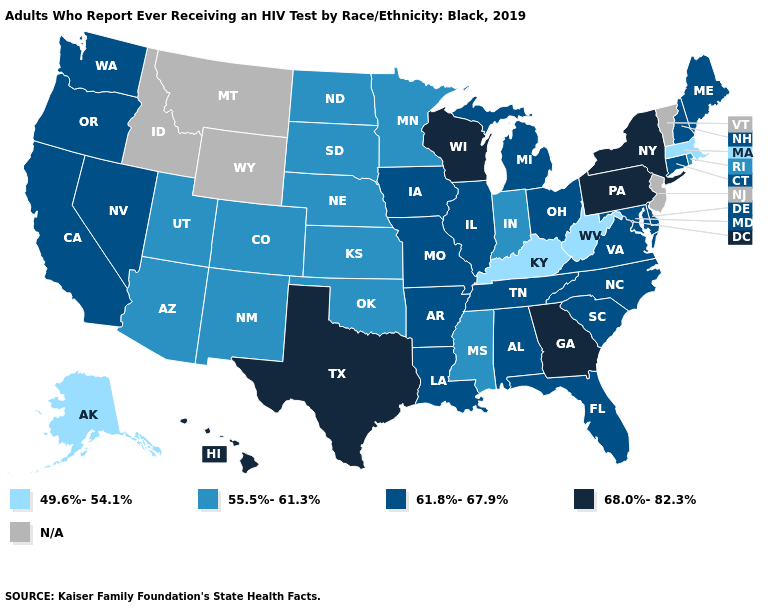Does Hawaii have the highest value in the USA?
Give a very brief answer. Yes. Does Kansas have the lowest value in the MidWest?
Keep it brief. Yes. What is the highest value in the South ?
Concise answer only. 68.0%-82.3%. Name the states that have a value in the range 61.8%-67.9%?
Concise answer only. Alabama, Arkansas, California, Connecticut, Delaware, Florida, Illinois, Iowa, Louisiana, Maine, Maryland, Michigan, Missouri, Nevada, New Hampshire, North Carolina, Ohio, Oregon, South Carolina, Tennessee, Virginia, Washington. Name the states that have a value in the range 61.8%-67.9%?
Answer briefly. Alabama, Arkansas, California, Connecticut, Delaware, Florida, Illinois, Iowa, Louisiana, Maine, Maryland, Michigan, Missouri, Nevada, New Hampshire, North Carolina, Ohio, Oregon, South Carolina, Tennessee, Virginia, Washington. What is the value of North Dakota?
Quick response, please. 55.5%-61.3%. Is the legend a continuous bar?
Write a very short answer. No. What is the highest value in the West ?
Write a very short answer. 68.0%-82.3%. What is the highest value in the West ?
Concise answer only. 68.0%-82.3%. Does Tennessee have the highest value in the USA?
Concise answer only. No. Does New York have the highest value in the Northeast?
Answer briefly. Yes. Name the states that have a value in the range 55.5%-61.3%?
Short answer required. Arizona, Colorado, Indiana, Kansas, Minnesota, Mississippi, Nebraska, New Mexico, North Dakota, Oklahoma, Rhode Island, South Dakota, Utah. Among the states that border Florida , which have the lowest value?
Keep it brief. Alabama. Name the states that have a value in the range 61.8%-67.9%?
Keep it brief. Alabama, Arkansas, California, Connecticut, Delaware, Florida, Illinois, Iowa, Louisiana, Maine, Maryland, Michigan, Missouri, Nevada, New Hampshire, North Carolina, Ohio, Oregon, South Carolina, Tennessee, Virginia, Washington. What is the lowest value in states that border Tennessee?
Keep it brief. 49.6%-54.1%. 